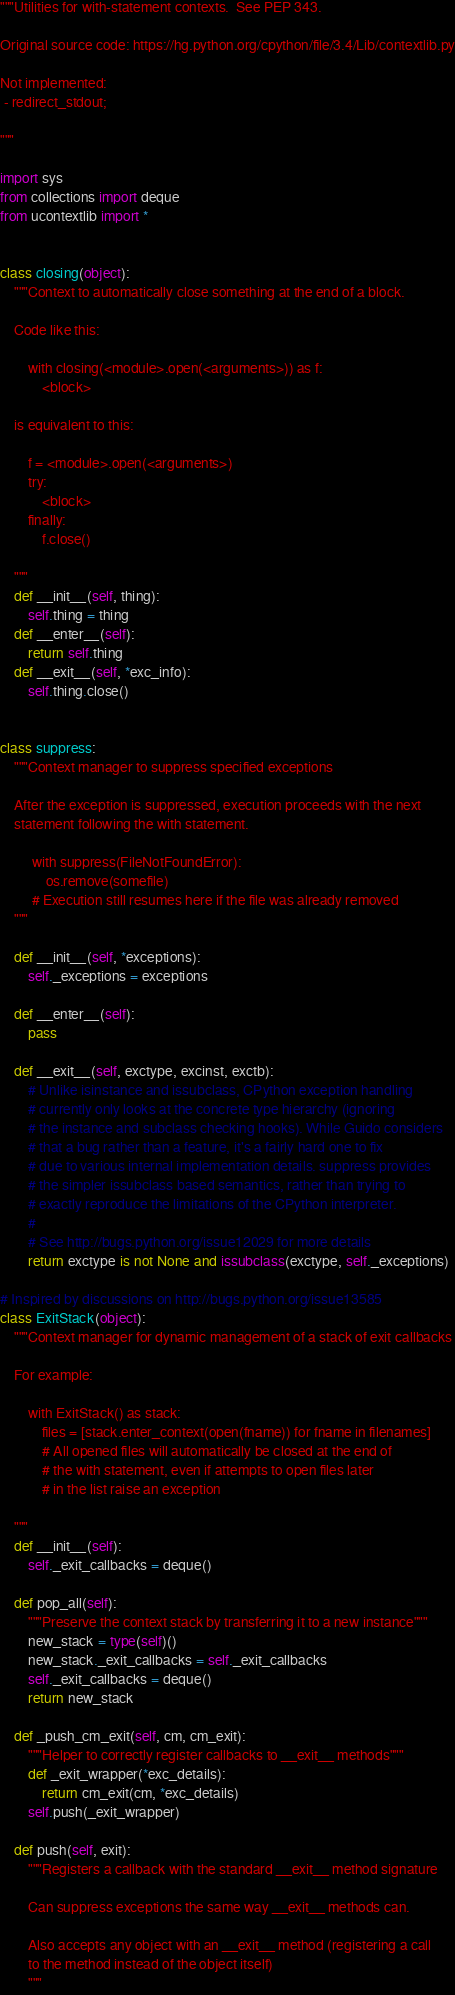<code> <loc_0><loc_0><loc_500><loc_500><_Python_>"""Utilities for with-statement contexts.  See PEP 343.

Original source code: https://hg.python.org/cpython/file/3.4/Lib/contextlib.py

Not implemented:
 - redirect_stdout;

"""

import sys
from collections import deque
from ucontextlib import *


class closing(object):
    """Context to automatically close something at the end of a block.

    Code like this:

        with closing(<module>.open(<arguments>)) as f:
            <block>

    is equivalent to this:

        f = <module>.open(<arguments>)
        try:
            <block>
        finally:
            f.close()

    """
    def __init__(self, thing):
        self.thing = thing
    def __enter__(self):
        return self.thing
    def __exit__(self, *exc_info):
        self.thing.close()


class suppress:
    """Context manager to suppress specified exceptions

    After the exception is suppressed, execution proceeds with the next
    statement following the with statement.

         with suppress(FileNotFoundError):
             os.remove(somefile)
         # Execution still resumes here if the file was already removed
    """

    def __init__(self, *exceptions):
        self._exceptions = exceptions

    def __enter__(self):
        pass

    def __exit__(self, exctype, excinst, exctb):
        # Unlike isinstance and issubclass, CPython exception handling
        # currently only looks at the concrete type hierarchy (ignoring
        # the instance and subclass checking hooks). While Guido considers
        # that a bug rather than a feature, it's a fairly hard one to fix
        # due to various internal implementation details. suppress provides
        # the simpler issubclass based semantics, rather than trying to
        # exactly reproduce the limitations of the CPython interpreter.
        #
        # See http://bugs.python.org/issue12029 for more details
        return exctype is not None and issubclass(exctype, self._exceptions)

# Inspired by discussions on http://bugs.python.org/issue13585
class ExitStack(object):
    """Context manager for dynamic management of a stack of exit callbacks

    For example:

        with ExitStack() as stack:
            files = [stack.enter_context(open(fname)) for fname in filenames]
            # All opened files will automatically be closed at the end of
            # the with statement, even if attempts to open files later
            # in the list raise an exception

    """
    def __init__(self):
        self._exit_callbacks = deque()

    def pop_all(self):
        """Preserve the context stack by transferring it to a new instance"""
        new_stack = type(self)()
        new_stack._exit_callbacks = self._exit_callbacks
        self._exit_callbacks = deque()
        return new_stack

    def _push_cm_exit(self, cm, cm_exit):
        """Helper to correctly register callbacks to __exit__ methods"""
        def _exit_wrapper(*exc_details):
            return cm_exit(cm, *exc_details)
        self.push(_exit_wrapper)

    def push(self, exit):
        """Registers a callback with the standard __exit__ method signature

        Can suppress exceptions the same way __exit__ methods can.

        Also accepts any object with an __exit__ method (registering a call
        to the method instead of the object itself)
        """</code> 